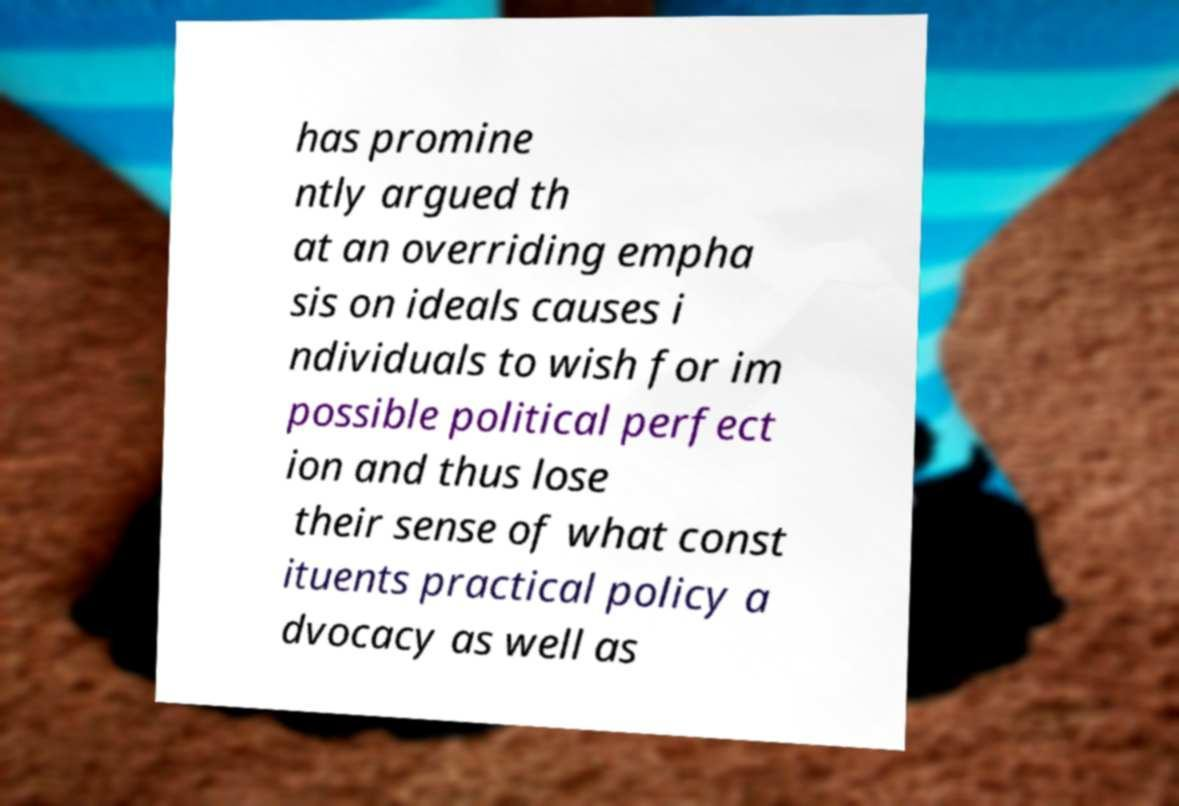Could you assist in decoding the text presented in this image and type it out clearly? has promine ntly argued th at an overriding empha sis on ideals causes i ndividuals to wish for im possible political perfect ion and thus lose their sense of what const ituents practical policy a dvocacy as well as 